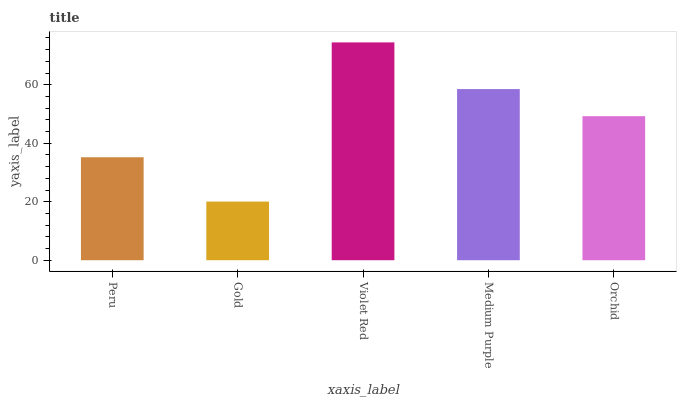Is Gold the minimum?
Answer yes or no. Yes. Is Violet Red the maximum?
Answer yes or no. Yes. Is Violet Red the minimum?
Answer yes or no. No. Is Gold the maximum?
Answer yes or no. No. Is Violet Red greater than Gold?
Answer yes or no. Yes. Is Gold less than Violet Red?
Answer yes or no. Yes. Is Gold greater than Violet Red?
Answer yes or no. No. Is Violet Red less than Gold?
Answer yes or no. No. Is Orchid the high median?
Answer yes or no. Yes. Is Orchid the low median?
Answer yes or no. Yes. Is Peru the high median?
Answer yes or no. No. Is Violet Red the low median?
Answer yes or no. No. 